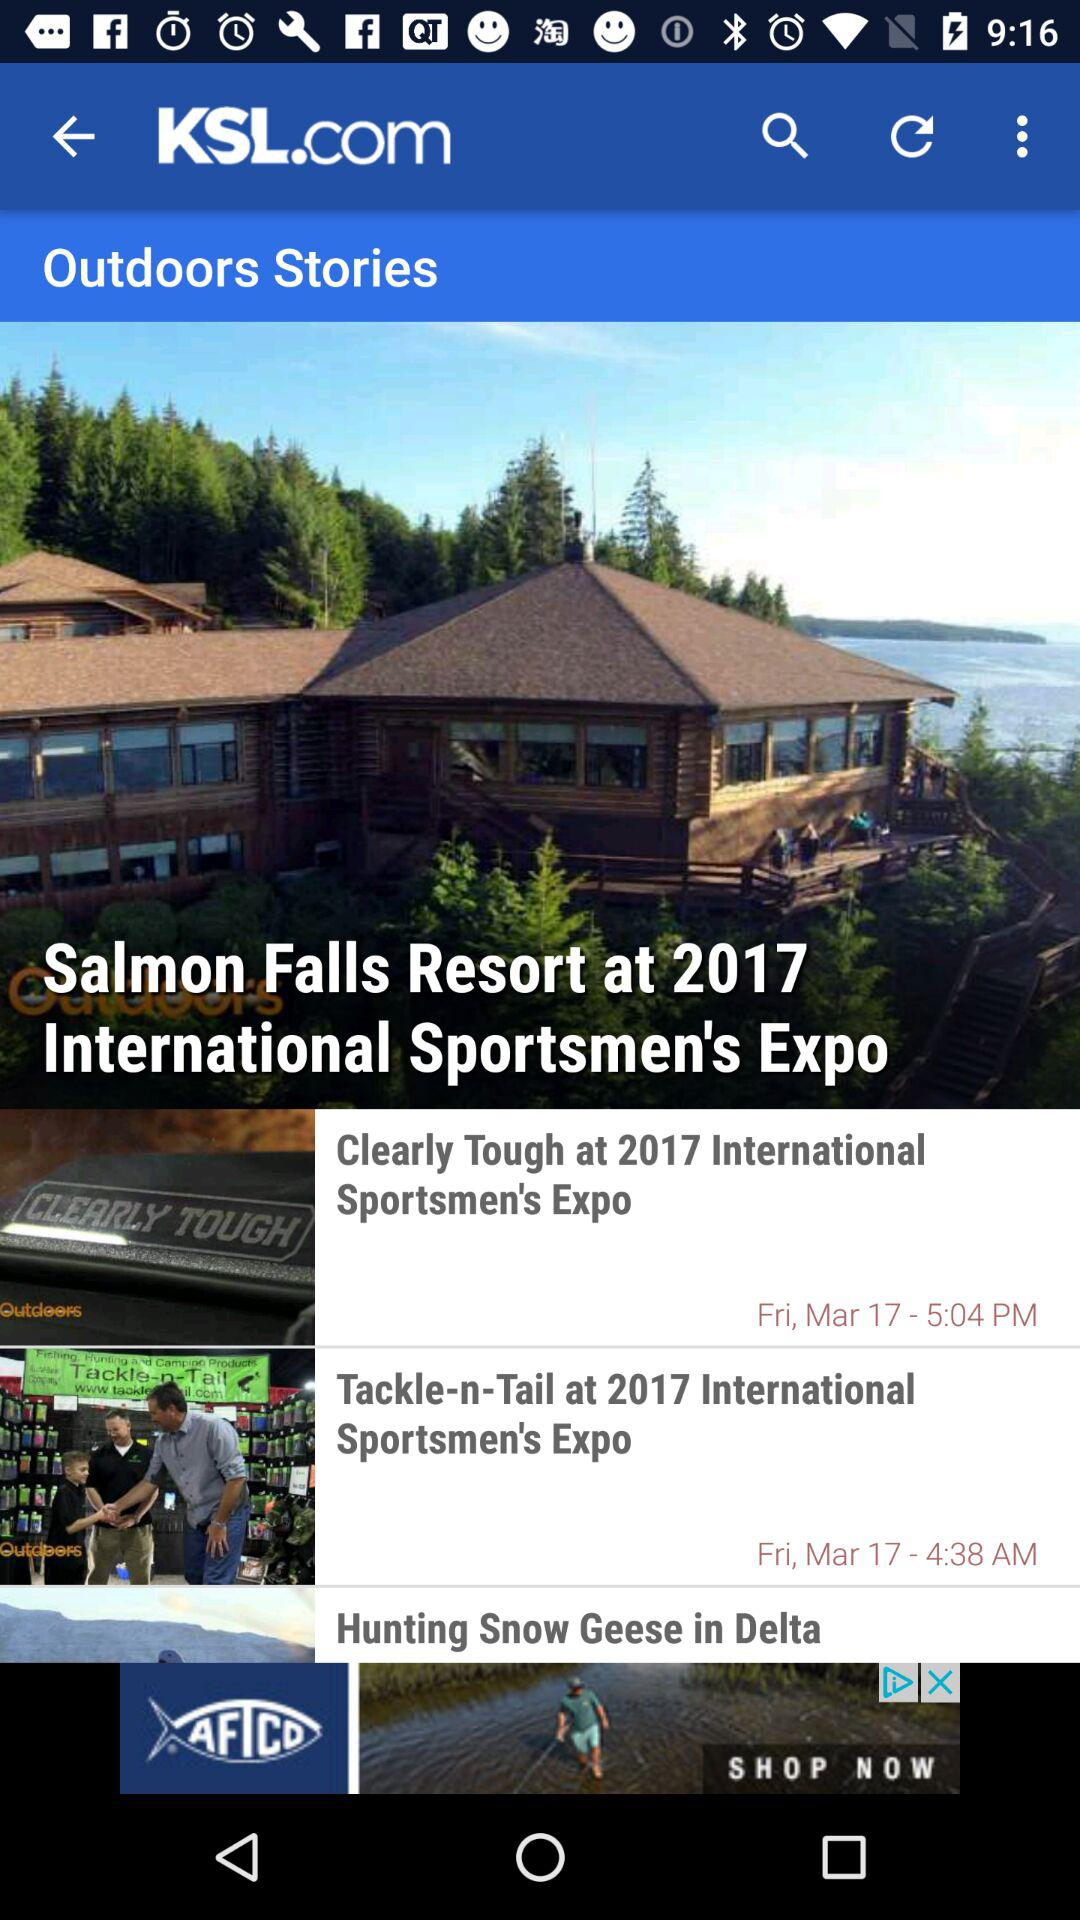What is the posting time of "Tackle-n-Tail at 2017"? The posting time is 4:38 AM. 